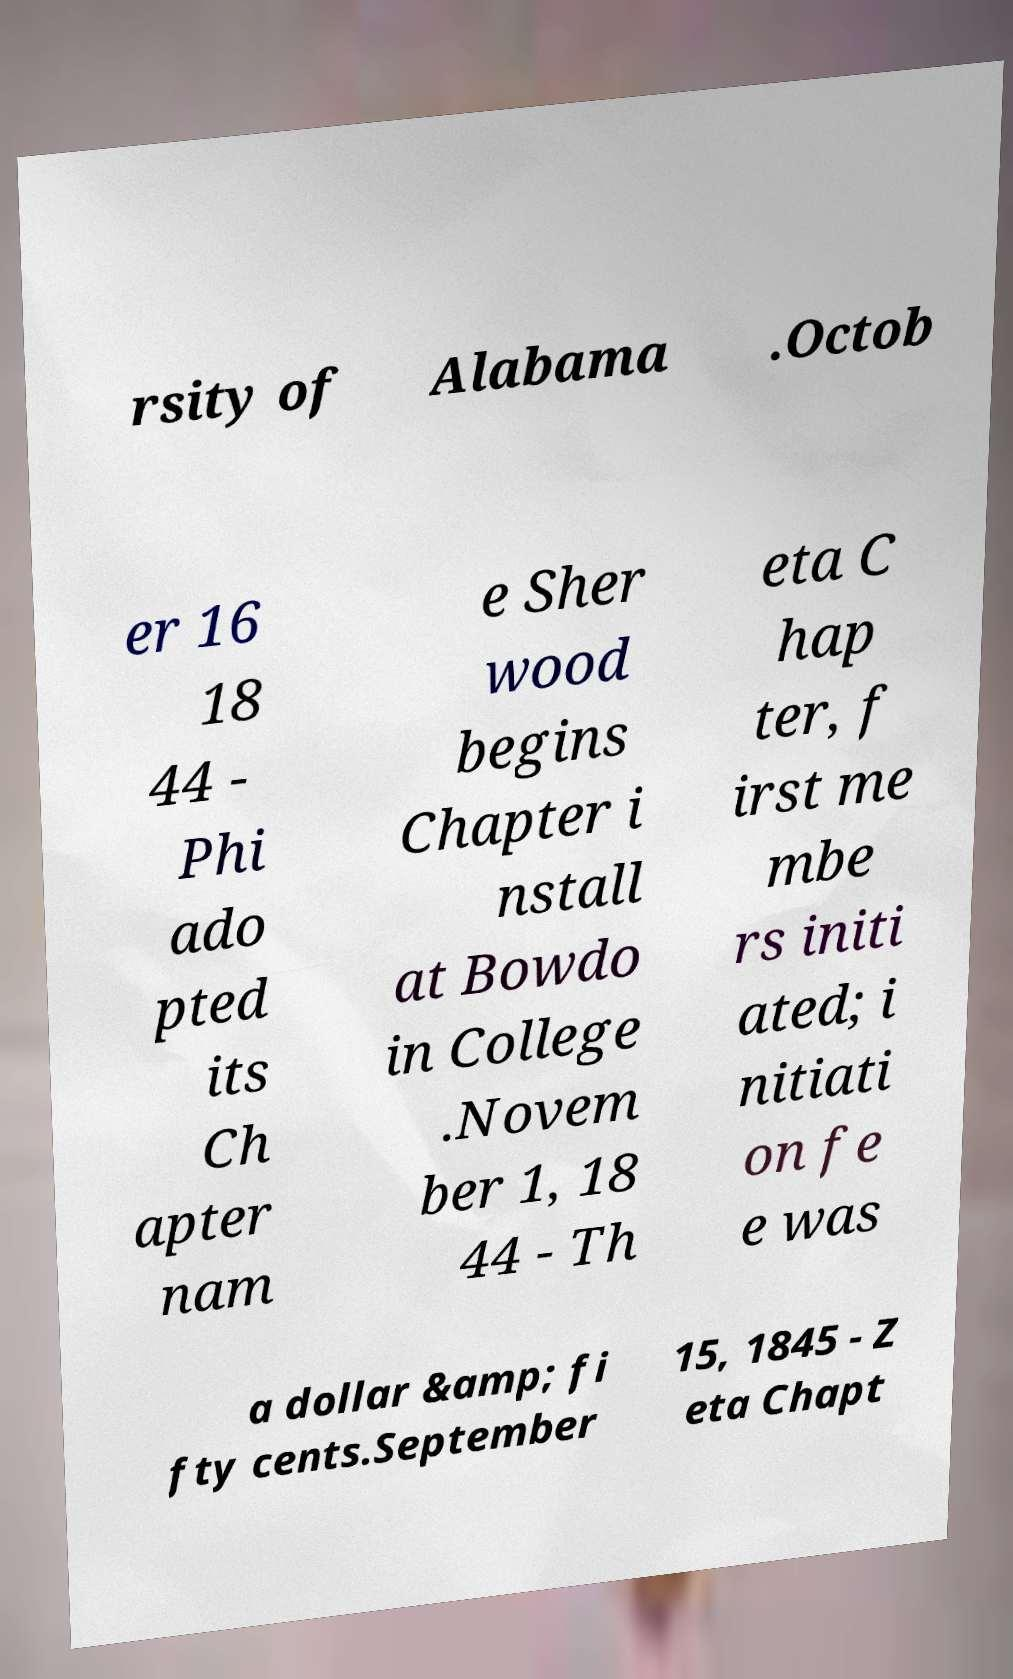For documentation purposes, I need the text within this image transcribed. Could you provide that? rsity of Alabama .Octob er 16 18 44 - Phi ado pted its Ch apter nam e Sher wood begins Chapter i nstall at Bowdo in College .Novem ber 1, 18 44 - Th eta C hap ter, f irst me mbe rs initi ated; i nitiati on fe e was a dollar &amp; fi fty cents.September 15, 1845 - Z eta Chapt 